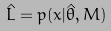<formula> <loc_0><loc_0><loc_500><loc_500>\hat { L } = p ( x | \hat { \theta } , M )</formula> 